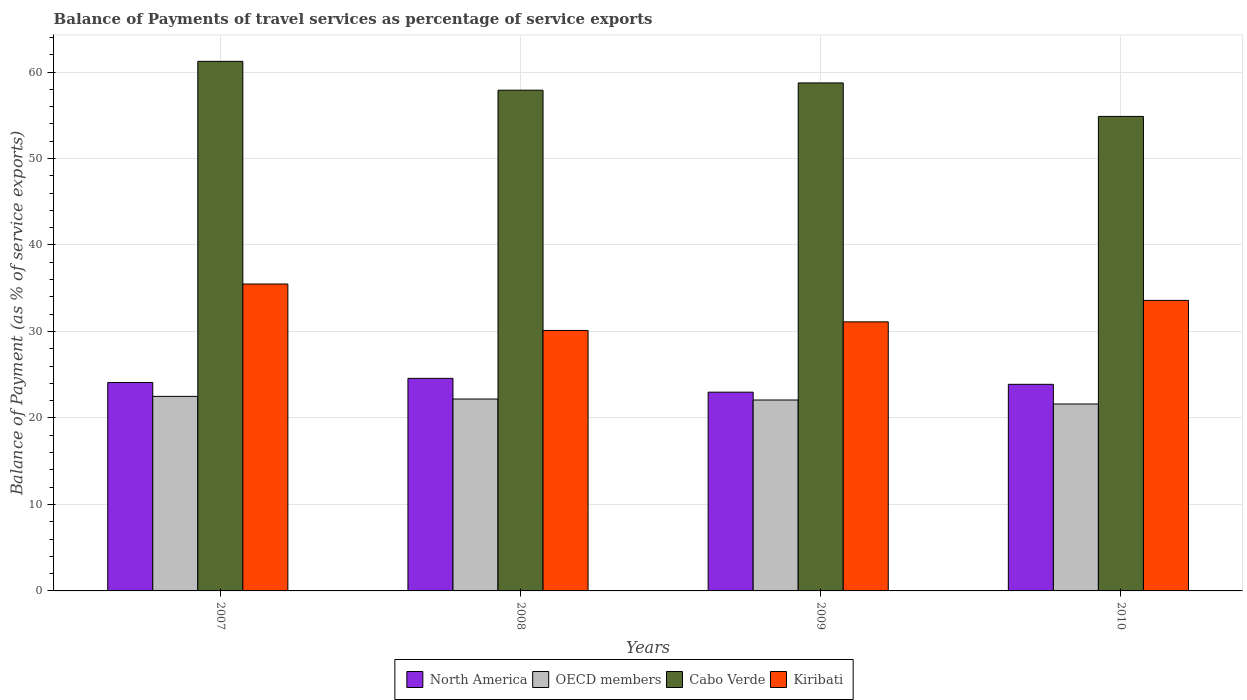How many groups of bars are there?
Offer a very short reply. 4. Are the number of bars per tick equal to the number of legend labels?
Your answer should be compact. Yes. Are the number of bars on each tick of the X-axis equal?
Your answer should be compact. Yes. What is the label of the 4th group of bars from the left?
Provide a succinct answer. 2010. What is the balance of payments of travel services in Kiribati in 2008?
Your answer should be very brief. 30.12. Across all years, what is the maximum balance of payments of travel services in Cabo Verde?
Provide a succinct answer. 61.23. Across all years, what is the minimum balance of payments of travel services in North America?
Give a very brief answer. 22.98. In which year was the balance of payments of travel services in Kiribati maximum?
Offer a terse response. 2007. In which year was the balance of payments of travel services in Kiribati minimum?
Provide a short and direct response. 2008. What is the total balance of payments of travel services in OECD members in the graph?
Your response must be concise. 88.37. What is the difference between the balance of payments of travel services in Cabo Verde in 2009 and that in 2010?
Your response must be concise. 3.87. What is the difference between the balance of payments of travel services in Cabo Verde in 2010 and the balance of payments of travel services in North America in 2009?
Offer a terse response. 31.89. What is the average balance of payments of travel services in North America per year?
Your answer should be compact. 23.89. In the year 2009, what is the difference between the balance of payments of travel services in Kiribati and balance of payments of travel services in North America?
Give a very brief answer. 8.13. What is the ratio of the balance of payments of travel services in Kiribati in 2009 to that in 2010?
Provide a succinct answer. 0.93. What is the difference between the highest and the second highest balance of payments of travel services in North America?
Provide a succinct answer. 0.48. What is the difference between the highest and the lowest balance of payments of travel services in OECD members?
Your response must be concise. 0.88. In how many years, is the balance of payments of travel services in Kiribati greater than the average balance of payments of travel services in Kiribati taken over all years?
Provide a short and direct response. 2. What does the 2nd bar from the left in 2007 represents?
Your answer should be very brief. OECD members. What does the 2nd bar from the right in 2010 represents?
Keep it short and to the point. Cabo Verde. Is it the case that in every year, the sum of the balance of payments of travel services in Cabo Verde and balance of payments of travel services in Kiribati is greater than the balance of payments of travel services in OECD members?
Provide a succinct answer. Yes. Are all the bars in the graph horizontal?
Offer a very short reply. No. How many years are there in the graph?
Give a very brief answer. 4. Are the values on the major ticks of Y-axis written in scientific E-notation?
Your answer should be compact. No. Does the graph contain any zero values?
Provide a succinct answer. No. What is the title of the graph?
Your response must be concise. Balance of Payments of travel services as percentage of service exports. What is the label or title of the X-axis?
Keep it short and to the point. Years. What is the label or title of the Y-axis?
Give a very brief answer. Balance of Payment (as % of service exports). What is the Balance of Payment (as % of service exports) in North America in 2007?
Keep it short and to the point. 24.1. What is the Balance of Payment (as % of service exports) in OECD members in 2007?
Your answer should be compact. 22.5. What is the Balance of Payment (as % of service exports) in Cabo Verde in 2007?
Your response must be concise. 61.23. What is the Balance of Payment (as % of service exports) in Kiribati in 2007?
Ensure brevity in your answer.  35.49. What is the Balance of Payment (as % of service exports) of North America in 2008?
Provide a short and direct response. 24.58. What is the Balance of Payment (as % of service exports) in OECD members in 2008?
Keep it short and to the point. 22.19. What is the Balance of Payment (as % of service exports) of Cabo Verde in 2008?
Provide a short and direct response. 57.9. What is the Balance of Payment (as % of service exports) in Kiribati in 2008?
Your response must be concise. 30.12. What is the Balance of Payment (as % of service exports) in North America in 2009?
Make the answer very short. 22.98. What is the Balance of Payment (as % of service exports) of OECD members in 2009?
Your answer should be compact. 22.07. What is the Balance of Payment (as % of service exports) in Cabo Verde in 2009?
Your response must be concise. 58.74. What is the Balance of Payment (as % of service exports) in Kiribati in 2009?
Provide a short and direct response. 31.11. What is the Balance of Payment (as % of service exports) of North America in 2010?
Your answer should be very brief. 23.89. What is the Balance of Payment (as % of service exports) in OECD members in 2010?
Provide a short and direct response. 21.61. What is the Balance of Payment (as % of service exports) of Cabo Verde in 2010?
Your response must be concise. 54.87. What is the Balance of Payment (as % of service exports) in Kiribati in 2010?
Your answer should be very brief. 33.59. Across all years, what is the maximum Balance of Payment (as % of service exports) of North America?
Your answer should be compact. 24.58. Across all years, what is the maximum Balance of Payment (as % of service exports) in OECD members?
Give a very brief answer. 22.5. Across all years, what is the maximum Balance of Payment (as % of service exports) in Cabo Verde?
Offer a terse response. 61.23. Across all years, what is the maximum Balance of Payment (as % of service exports) in Kiribati?
Provide a short and direct response. 35.49. Across all years, what is the minimum Balance of Payment (as % of service exports) in North America?
Give a very brief answer. 22.98. Across all years, what is the minimum Balance of Payment (as % of service exports) in OECD members?
Your answer should be very brief. 21.61. Across all years, what is the minimum Balance of Payment (as % of service exports) in Cabo Verde?
Provide a succinct answer. 54.87. Across all years, what is the minimum Balance of Payment (as % of service exports) in Kiribati?
Provide a succinct answer. 30.12. What is the total Balance of Payment (as % of service exports) in North America in the graph?
Ensure brevity in your answer.  95.54. What is the total Balance of Payment (as % of service exports) in OECD members in the graph?
Provide a succinct answer. 88.37. What is the total Balance of Payment (as % of service exports) of Cabo Verde in the graph?
Provide a short and direct response. 232.73. What is the total Balance of Payment (as % of service exports) in Kiribati in the graph?
Offer a terse response. 130.31. What is the difference between the Balance of Payment (as % of service exports) in North America in 2007 and that in 2008?
Keep it short and to the point. -0.48. What is the difference between the Balance of Payment (as % of service exports) of OECD members in 2007 and that in 2008?
Offer a terse response. 0.31. What is the difference between the Balance of Payment (as % of service exports) of Cabo Verde in 2007 and that in 2008?
Offer a terse response. 3.33. What is the difference between the Balance of Payment (as % of service exports) in Kiribati in 2007 and that in 2008?
Offer a very short reply. 5.37. What is the difference between the Balance of Payment (as % of service exports) of North America in 2007 and that in 2009?
Provide a short and direct response. 1.11. What is the difference between the Balance of Payment (as % of service exports) in OECD members in 2007 and that in 2009?
Provide a short and direct response. 0.42. What is the difference between the Balance of Payment (as % of service exports) of Cabo Verde in 2007 and that in 2009?
Your response must be concise. 2.49. What is the difference between the Balance of Payment (as % of service exports) of Kiribati in 2007 and that in 2009?
Ensure brevity in your answer.  4.38. What is the difference between the Balance of Payment (as % of service exports) of North America in 2007 and that in 2010?
Provide a short and direct response. 0.21. What is the difference between the Balance of Payment (as % of service exports) in OECD members in 2007 and that in 2010?
Ensure brevity in your answer.  0.88. What is the difference between the Balance of Payment (as % of service exports) of Cabo Verde in 2007 and that in 2010?
Your answer should be compact. 6.37. What is the difference between the Balance of Payment (as % of service exports) of Kiribati in 2007 and that in 2010?
Your response must be concise. 1.9. What is the difference between the Balance of Payment (as % of service exports) in North America in 2008 and that in 2009?
Give a very brief answer. 1.6. What is the difference between the Balance of Payment (as % of service exports) of OECD members in 2008 and that in 2009?
Give a very brief answer. 0.11. What is the difference between the Balance of Payment (as % of service exports) in Cabo Verde in 2008 and that in 2009?
Your answer should be compact. -0.84. What is the difference between the Balance of Payment (as % of service exports) of Kiribati in 2008 and that in 2009?
Your answer should be very brief. -0.99. What is the difference between the Balance of Payment (as % of service exports) in North America in 2008 and that in 2010?
Your answer should be very brief. 0.69. What is the difference between the Balance of Payment (as % of service exports) of OECD members in 2008 and that in 2010?
Offer a very short reply. 0.57. What is the difference between the Balance of Payment (as % of service exports) of Cabo Verde in 2008 and that in 2010?
Your answer should be compact. 3.03. What is the difference between the Balance of Payment (as % of service exports) in Kiribati in 2008 and that in 2010?
Provide a short and direct response. -3.47. What is the difference between the Balance of Payment (as % of service exports) of North America in 2009 and that in 2010?
Your answer should be compact. -0.91. What is the difference between the Balance of Payment (as % of service exports) of OECD members in 2009 and that in 2010?
Your answer should be compact. 0.46. What is the difference between the Balance of Payment (as % of service exports) of Cabo Verde in 2009 and that in 2010?
Offer a very short reply. 3.87. What is the difference between the Balance of Payment (as % of service exports) in Kiribati in 2009 and that in 2010?
Provide a short and direct response. -2.48. What is the difference between the Balance of Payment (as % of service exports) in North America in 2007 and the Balance of Payment (as % of service exports) in OECD members in 2008?
Ensure brevity in your answer.  1.91. What is the difference between the Balance of Payment (as % of service exports) of North America in 2007 and the Balance of Payment (as % of service exports) of Cabo Verde in 2008?
Your answer should be compact. -33.8. What is the difference between the Balance of Payment (as % of service exports) of North America in 2007 and the Balance of Payment (as % of service exports) of Kiribati in 2008?
Your answer should be very brief. -6.02. What is the difference between the Balance of Payment (as % of service exports) of OECD members in 2007 and the Balance of Payment (as % of service exports) of Cabo Verde in 2008?
Offer a terse response. -35.4. What is the difference between the Balance of Payment (as % of service exports) of OECD members in 2007 and the Balance of Payment (as % of service exports) of Kiribati in 2008?
Your response must be concise. -7.62. What is the difference between the Balance of Payment (as % of service exports) of Cabo Verde in 2007 and the Balance of Payment (as % of service exports) of Kiribati in 2008?
Provide a succinct answer. 31.11. What is the difference between the Balance of Payment (as % of service exports) in North America in 2007 and the Balance of Payment (as % of service exports) in OECD members in 2009?
Your answer should be compact. 2.02. What is the difference between the Balance of Payment (as % of service exports) in North America in 2007 and the Balance of Payment (as % of service exports) in Cabo Verde in 2009?
Offer a terse response. -34.64. What is the difference between the Balance of Payment (as % of service exports) of North America in 2007 and the Balance of Payment (as % of service exports) of Kiribati in 2009?
Offer a terse response. -7.02. What is the difference between the Balance of Payment (as % of service exports) in OECD members in 2007 and the Balance of Payment (as % of service exports) in Cabo Verde in 2009?
Provide a succinct answer. -36.24. What is the difference between the Balance of Payment (as % of service exports) in OECD members in 2007 and the Balance of Payment (as % of service exports) in Kiribati in 2009?
Offer a terse response. -8.62. What is the difference between the Balance of Payment (as % of service exports) in Cabo Verde in 2007 and the Balance of Payment (as % of service exports) in Kiribati in 2009?
Offer a terse response. 30.12. What is the difference between the Balance of Payment (as % of service exports) in North America in 2007 and the Balance of Payment (as % of service exports) in OECD members in 2010?
Your answer should be compact. 2.48. What is the difference between the Balance of Payment (as % of service exports) in North America in 2007 and the Balance of Payment (as % of service exports) in Cabo Verde in 2010?
Ensure brevity in your answer.  -30.77. What is the difference between the Balance of Payment (as % of service exports) of North America in 2007 and the Balance of Payment (as % of service exports) of Kiribati in 2010?
Provide a short and direct response. -9.5. What is the difference between the Balance of Payment (as % of service exports) in OECD members in 2007 and the Balance of Payment (as % of service exports) in Cabo Verde in 2010?
Your response must be concise. -32.37. What is the difference between the Balance of Payment (as % of service exports) of OECD members in 2007 and the Balance of Payment (as % of service exports) of Kiribati in 2010?
Your answer should be compact. -11.1. What is the difference between the Balance of Payment (as % of service exports) in Cabo Verde in 2007 and the Balance of Payment (as % of service exports) in Kiribati in 2010?
Your answer should be very brief. 27.64. What is the difference between the Balance of Payment (as % of service exports) in North America in 2008 and the Balance of Payment (as % of service exports) in OECD members in 2009?
Your answer should be very brief. 2.5. What is the difference between the Balance of Payment (as % of service exports) of North America in 2008 and the Balance of Payment (as % of service exports) of Cabo Verde in 2009?
Your answer should be compact. -34.16. What is the difference between the Balance of Payment (as % of service exports) of North America in 2008 and the Balance of Payment (as % of service exports) of Kiribati in 2009?
Offer a very short reply. -6.54. What is the difference between the Balance of Payment (as % of service exports) in OECD members in 2008 and the Balance of Payment (as % of service exports) in Cabo Verde in 2009?
Your answer should be compact. -36.55. What is the difference between the Balance of Payment (as % of service exports) in OECD members in 2008 and the Balance of Payment (as % of service exports) in Kiribati in 2009?
Offer a very short reply. -8.92. What is the difference between the Balance of Payment (as % of service exports) of Cabo Verde in 2008 and the Balance of Payment (as % of service exports) of Kiribati in 2009?
Offer a terse response. 26.79. What is the difference between the Balance of Payment (as % of service exports) in North America in 2008 and the Balance of Payment (as % of service exports) in OECD members in 2010?
Your answer should be compact. 2.96. What is the difference between the Balance of Payment (as % of service exports) in North America in 2008 and the Balance of Payment (as % of service exports) in Cabo Verde in 2010?
Ensure brevity in your answer.  -30.29. What is the difference between the Balance of Payment (as % of service exports) in North America in 2008 and the Balance of Payment (as % of service exports) in Kiribati in 2010?
Your answer should be very brief. -9.02. What is the difference between the Balance of Payment (as % of service exports) of OECD members in 2008 and the Balance of Payment (as % of service exports) of Cabo Verde in 2010?
Your answer should be compact. -32.68. What is the difference between the Balance of Payment (as % of service exports) of OECD members in 2008 and the Balance of Payment (as % of service exports) of Kiribati in 2010?
Keep it short and to the point. -11.4. What is the difference between the Balance of Payment (as % of service exports) of Cabo Verde in 2008 and the Balance of Payment (as % of service exports) of Kiribati in 2010?
Keep it short and to the point. 24.31. What is the difference between the Balance of Payment (as % of service exports) of North America in 2009 and the Balance of Payment (as % of service exports) of OECD members in 2010?
Make the answer very short. 1.37. What is the difference between the Balance of Payment (as % of service exports) in North America in 2009 and the Balance of Payment (as % of service exports) in Cabo Verde in 2010?
Give a very brief answer. -31.89. What is the difference between the Balance of Payment (as % of service exports) of North America in 2009 and the Balance of Payment (as % of service exports) of Kiribati in 2010?
Make the answer very short. -10.61. What is the difference between the Balance of Payment (as % of service exports) of OECD members in 2009 and the Balance of Payment (as % of service exports) of Cabo Verde in 2010?
Provide a succinct answer. -32.79. What is the difference between the Balance of Payment (as % of service exports) in OECD members in 2009 and the Balance of Payment (as % of service exports) in Kiribati in 2010?
Offer a terse response. -11.52. What is the difference between the Balance of Payment (as % of service exports) of Cabo Verde in 2009 and the Balance of Payment (as % of service exports) of Kiribati in 2010?
Provide a short and direct response. 25.15. What is the average Balance of Payment (as % of service exports) of North America per year?
Provide a succinct answer. 23.89. What is the average Balance of Payment (as % of service exports) of OECD members per year?
Provide a succinct answer. 22.09. What is the average Balance of Payment (as % of service exports) in Cabo Verde per year?
Make the answer very short. 58.18. What is the average Balance of Payment (as % of service exports) of Kiribati per year?
Provide a succinct answer. 32.58. In the year 2007, what is the difference between the Balance of Payment (as % of service exports) in North America and Balance of Payment (as % of service exports) in OECD members?
Provide a short and direct response. 1.6. In the year 2007, what is the difference between the Balance of Payment (as % of service exports) of North America and Balance of Payment (as % of service exports) of Cabo Verde?
Ensure brevity in your answer.  -37.14. In the year 2007, what is the difference between the Balance of Payment (as % of service exports) of North America and Balance of Payment (as % of service exports) of Kiribati?
Keep it short and to the point. -11.39. In the year 2007, what is the difference between the Balance of Payment (as % of service exports) of OECD members and Balance of Payment (as % of service exports) of Cabo Verde?
Offer a terse response. -38.74. In the year 2007, what is the difference between the Balance of Payment (as % of service exports) of OECD members and Balance of Payment (as % of service exports) of Kiribati?
Offer a very short reply. -12.99. In the year 2007, what is the difference between the Balance of Payment (as % of service exports) in Cabo Verde and Balance of Payment (as % of service exports) in Kiribati?
Your answer should be very brief. 25.74. In the year 2008, what is the difference between the Balance of Payment (as % of service exports) in North America and Balance of Payment (as % of service exports) in OECD members?
Offer a terse response. 2.39. In the year 2008, what is the difference between the Balance of Payment (as % of service exports) in North America and Balance of Payment (as % of service exports) in Cabo Verde?
Ensure brevity in your answer.  -33.32. In the year 2008, what is the difference between the Balance of Payment (as % of service exports) of North America and Balance of Payment (as % of service exports) of Kiribati?
Keep it short and to the point. -5.54. In the year 2008, what is the difference between the Balance of Payment (as % of service exports) of OECD members and Balance of Payment (as % of service exports) of Cabo Verde?
Give a very brief answer. -35.71. In the year 2008, what is the difference between the Balance of Payment (as % of service exports) in OECD members and Balance of Payment (as % of service exports) in Kiribati?
Make the answer very short. -7.93. In the year 2008, what is the difference between the Balance of Payment (as % of service exports) in Cabo Verde and Balance of Payment (as % of service exports) in Kiribati?
Keep it short and to the point. 27.78. In the year 2009, what is the difference between the Balance of Payment (as % of service exports) of North America and Balance of Payment (as % of service exports) of OECD members?
Your response must be concise. 0.91. In the year 2009, what is the difference between the Balance of Payment (as % of service exports) in North America and Balance of Payment (as % of service exports) in Cabo Verde?
Ensure brevity in your answer.  -35.76. In the year 2009, what is the difference between the Balance of Payment (as % of service exports) of North America and Balance of Payment (as % of service exports) of Kiribati?
Provide a succinct answer. -8.13. In the year 2009, what is the difference between the Balance of Payment (as % of service exports) in OECD members and Balance of Payment (as % of service exports) in Cabo Verde?
Provide a short and direct response. -36.66. In the year 2009, what is the difference between the Balance of Payment (as % of service exports) of OECD members and Balance of Payment (as % of service exports) of Kiribati?
Your answer should be very brief. -9.04. In the year 2009, what is the difference between the Balance of Payment (as % of service exports) of Cabo Verde and Balance of Payment (as % of service exports) of Kiribati?
Provide a short and direct response. 27.63. In the year 2010, what is the difference between the Balance of Payment (as % of service exports) in North America and Balance of Payment (as % of service exports) in OECD members?
Make the answer very short. 2.27. In the year 2010, what is the difference between the Balance of Payment (as % of service exports) in North America and Balance of Payment (as % of service exports) in Cabo Verde?
Make the answer very short. -30.98. In the year 2010, what is the difference between the Balance of Payment (as % of service exports) in North America and Balance of Payment (as % of service exports) in Kiribati?
Give a very brief answer. -9.7. In the year 2010, what is the difference between the Balance of Payment (as % of service exports) of OECD members and Balance of Payment (as % of service exports) of Cabo Verde?
Provide a succinct answer. -33.25. In the year 2010, what is the difference between the Balance of Payment (as % of service exports) in OECD members and Balance of Payment (as % of service exports) in Kiribati?
Offer a very short reply. -11.98. In the year 2010, what is the difference between the Balance of Payment (as % of service exports) in Cabo Verde and Balance of Payment (as % of service exports) in Kiribati?
Your response must be concise. 21.27. What is the ratio of the Balance of Payment (as % of service exports) in North America in 2007 to that in 2008?
Offer a very short reply. 0.98. What is the ratio of the Balance of Payment (as % of service exports) in OECD members in 2007 to that in 2008?
Provide a short and direct response. 1.01. What is the ratio of the Balance of Payment (as % of service exports) of Cabo Verde in 2007 to that in 2008?
Offer a terse response. 1.06. What is the ratio of the Balance of Payment (as % of service exports) of Kiribati in 2007 to that in 2008?
Provide a succinct answer. 1.18. What is the ratio of the Balance of Payment (as % of service exports) of North America in 2007 to that in 2009?
Make the answer very short. 1.05. What is the ratio of the Balance of Payment (as % of service exports) of Cabo Verde in 2007 to that in 2009?
Keep it short and to the point. 1.04. What is the ratio of the Balance of Payment (as % of service exports) in Kiribati in 2007 to that in 2009?
Make the answer very short. 1.14. What is the ratio of the Balance of Payment (as % of service exports) of North America in 2007 to that in 2010?
Provide a succinct answer. 1.01. What is the ratio of the Balance of Payment (as % of service exports) in OECD members in 2007 to that in 2010?
Offer a terse response. 1.04. What is the ratio of the Balance of Payment (as % of service exports) in Cabo Verde in 2007 to that in 2010?
Your answer should be very brief. 1.12. What is the ratio of the Balance of Payment (as % of service exports) in Kiribati in 2007 to that in 2010?
Give a very brief answer. 1.06. What is the ratio of the Balance of Payment (as % of service exports) in North America in 2008 to that in 2009?
Give a very brief answer. 1.07. What is the ratio of the Balance of Payment (as % of service exports) in OECD members in 2008 to that in 2009?
Provide a short and direct response. 1.01. What is the ratio of the Balance of Payment (as % of service exports) in Cabo Verde in 2008 to that in 2009?
Provide a succinct answer. 0.99. What is the ratio of the Balance of Payment (as % of service exports) of Kiribati in 2008 to that in 2009?
Keep it short and to the point. 0.97. What is the ratio of the Balance of Payment (as % of service exports) of North America in 2008 to that in 2010?
Provide a short and direct response. 1.03. What is the ratio of the Balance of Payment (as % of service exports) in OECD members in 2008 to that in 2010?
Your answer should be very brief. 1.03. What is the ratio of the Balance of Payment (as % of service exports) in Cabo Verde in 2008 to that in 2010?
Your answer should be compact. 1.06. What is the ratio of the Balance of Payment (as % of service exports) of Kiribati in 2008 to that in 2010?
Keep it short and to the point. 0.9. What is the ratio of the Balance of Payment (as % of service exports) in OECD members in 2009 to that in 2010?
Keep it short and to the point. 1.02. What is the ratio of the Balance of Payment (as % of service exports) of Cabo Verde in 2009 to that in 2010?
Make the answer very short. 1.07. What is the ratio of the Balance of Payment (as % of service exports) in Kiribati in 2009 to that in 2010?
Your answer should be very brief. 0.93. What is the difference between the highest and the second highest Balance of Payment (as % of service exports) of North America?
Give a very brief answer. 0.48. What is the difference between the highest and the second highest Balance of Payment (as % of service exports) of OECD members?
Give a very brief answer. 0.31. What is the difference between the highest and the second highest Balance of Payment (as % of service exports) in Cabo Verde?
Offer a terse response. 2.49. What is the difference between the highest and the second highest Balance of Payment (as % of service exports) in Kiribati?
Provide a succinct answer. 1.9. What is the difference between the highest and the lowest Balance of Payment (as % of service exports) in North America?
Provide a short and direct response. 1.6. What is the difference between the highest and the lowest Balance of Payment (as % of service exports) in OECD members?
Your answer should be compact. 0.88. What is the difference between the highest and the lowest Balance of Payment (as % of service exports) in Cabo Verde?
Offer a very short reply. 6.37. What is the difference between the highest and the lowest Balance of Payment (as % of service exports) in Kiribati?
Make the answer very short. 5.37. 